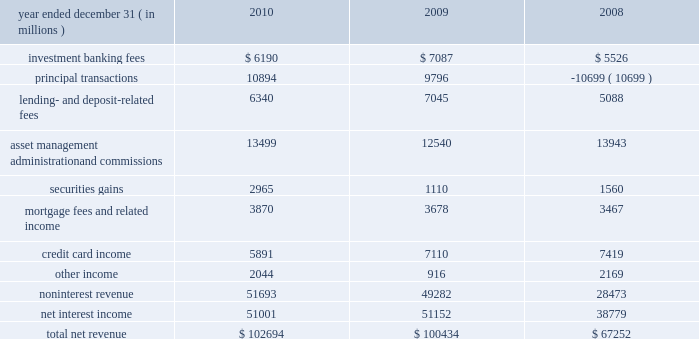Jpmorgan chase & co./2010 annual report 59 consolidated results of operations this following section provides a comparative discussion of jpmorgan chase 2019s consolidated results of operations on a reported basis for the three-year period ended december 31 , 2010 .
Factors that related primarily to a single business segment are discussed in more detail within that business segment .
For a discussion of the critical accounting estimates used by the firm that affect the consolidated results of operations , see pages 149 2013 154 of this annual report .
Revenue year ended december 31 , ( in millions ) 2010 2009 2008 .
2010 compared with 2009 total net revenue for 2010 was $ 102.7 billion , up by $ 2.3 billion , or 2% ( 2 % ) , from 2009 .
Results for 2010 were driven by a higher level of securities gains and private equity gains in corporate/private equity , higher asset management fees in am and administration fees in tss , and higher other income in several businesses , partially offset by lower credit card income .
Investment banking fees decreased from 2009 due to lower equity underwriting and advisory fees , partially offset by higher debt underwriting fees .
Competitive markets combined with flat industry-wide equity underwriting and completed m&a volumes , resulted in lower equity underwriting and advisory fees ; while strong industry-wide loan syndication and high-yield bond volumes drove record debt underwriting fees in ib .
For additional information on investment banking fees , which are primarily recorded in ib , see ib segment results on pages 69 201371 of this annual report .
Principal transactions revenue , which consists of revenue from the firm 2019s trading and private equity investing activities , increased compared with 2009 .
This was driven by the private equity business , which had significant private equity gains in 2010 , compared with a small loss in 2009 , reflecting improvements in market conditions .
Trading revenue decreased , reflecting lower results in corporate , offset by higher revenue in ib primarily reflecting gains from the widening of the firm 2019s credit spread on certain structured and derivative liabilities .
For additional information on principal transactions revenue , see ib and corporate/private equity segment results on pages 69 201371 and 89 2013 90 , respectively , and note 7 on pages 199 2013200 of this annual report .
Lending- and deposit-related fees decreased in 2010 from 2009 levels , reflecting lower deposit-related fees in rfs associated , in part , with newly-enacted legislation related to non-sufficient funds and overdraft fees ; this was partially offset by higher lending- related service fees in ib , primarily from growth in business volume , and in cb , primarily from higher commitment and letter-of-credit fees .
For additional information on lending- and deposit-related fees , which are mostly recorded in ib , rfs , cb and tss , see segment results for ib on pages 69 201371 , rfs on pages 72 201378 , cb on pages 82 201383 and tss on pages 84 201385 of this annual report .
Asset management , administration and commissions revenue increased from 2009 .
The increase largely reflected higher asset management fees in am , driven by the effect of higher market levels , net inflows to products with higher margins and higher performance fees ; and higher administration fees in tss , reflecting the effects of higher market levels and net inflows of assets under custody .
This increase was partially offset by lower brokerage commissions in ib , as a result of lower market volumes .
For additional information on these fees and commissions , see the segment discussions for am on pages 86 201388 and tss on pages 84 201385 of this annual report .
Securities gains were significantly higher in 2010 compared with 2009 , resulting primarily from the repositioning of the portfolio in response to changes in the interest rate environment and to rebalance exposure .
For additional information on securities gains , which are mostly recorded in the firm 2019s corporate segment , see the corporate/private equity segment discussion on pages 89 201390 of this annual report .
Mortgage fees and related income increased in 2010 compared with 2009 , driven by higher mortgage production revenue , reflecting increased mortgage origination volumes in rfs and am , and wider margins , particularly in rfs .
This increase was largely offset by higher repurchase losses in rfs ( recorded as contra- revenue ) , which were attributable to higher estimated losses related to repurchase demands , predominantly from gses .
For additional information on mortgage fees and related income , which is recorded primarily in rfs , see rfs 2019s mortgage banking , auto & other consumer lending discussion on pages 74 201377 of this annual report .
For additional information on repurchase losses , see the repurchase liability discussion on pages 98 2013101 and note 30 on pages 275 2013280 of this annual report .
Credit card income decreased during 2010 , predominantly due to the impact of the accounting guidance related to vies , effective january 1 , 2010 , that required the firm to consolidate the assets and liabilities of its firm-sponsored credit card securitization trusts .
Adoption of the new guidance resulted in the elimination of all servicing fees received from firm-sponsored credit card securitization trusts ( which was offset by related increases in net .
What was noninterest revenue as a percent of total net revenue in 2010? 
Computations: (51693 / 102694)
Answer: 0.50337. 